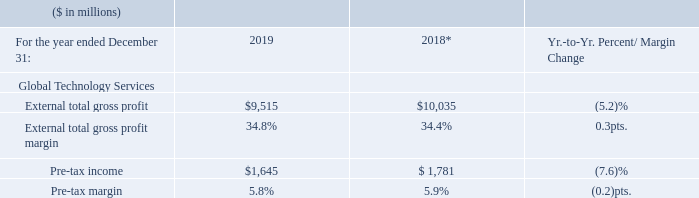* Recast to reflect segment changes.
The GTS gross profit margin increased 0.3 points year to year to 34.8 percent, due to the benefits of workforce actions and the continued scale out of our public cloud. We continued to take structural actions to improve our cost competitiveness and are accelerating the use of AI and automation in delivery operations, including leveraging Red Hat’s Ansible platform. Pre-tax income of $1,645 million decreased 7.6 percent, driven primarily by the decline in revenue and gross profit, and a higher level of workforce rebalancing charges in the current year. Pre-tax margin of 5.8 percent was essentially flat year to year, with the 2019 pre-tax margin reflecting benefits from structural and workforce actions.
What caused the decrease in the pre-tax income in 2019? Driven primarily by the decline in revenue and gross profit, and a higher level of workforce rebalancing charges in the current year. What was the pre-tax margin of 2019? 5.8%. What were the steps taken by the firm to improve the cost effectiveness? Continued to take structural actions to improve our cost competitiveness and are accelerating the use of ai and automation in delivery operations, including leveraging red hat’s ansible platform. What were the average External total gross profit?
Answer scale should be: million. (9,515 + 10,035) / 2
Answer: 9775. What was the increase / (decrease) rate in the Pre-tax income from 2018 to 2019?
Answer scale should be: percent. 1,645 / 1,781 - 1
Answer: -7.64. What was the increase / (decrease) in the Pre-tax margin from 2018 to 2019?
Answer scale should be: percent. 5.8% - 5.9%
Answer: -0.1. 